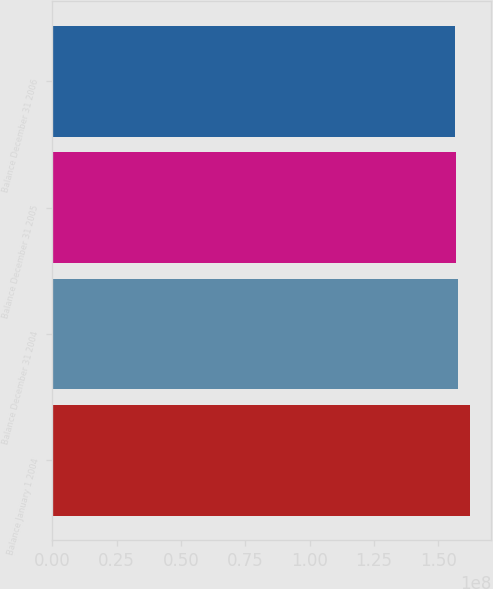Convert chart to OTSL. <chart><loc_0><loc_0><loc_500><loc_500><bar_chart><fcel>Balance January 1 2004<fcel>Balance December 31 2004<fcel>Balance December 31 2005<fcel>Balance December 31 2006<nl><fcel>1.62315e+08<fcel>1.57518e+08<fcel>1.56918e+08<fcel>1.56319e+08<nl></chart> 